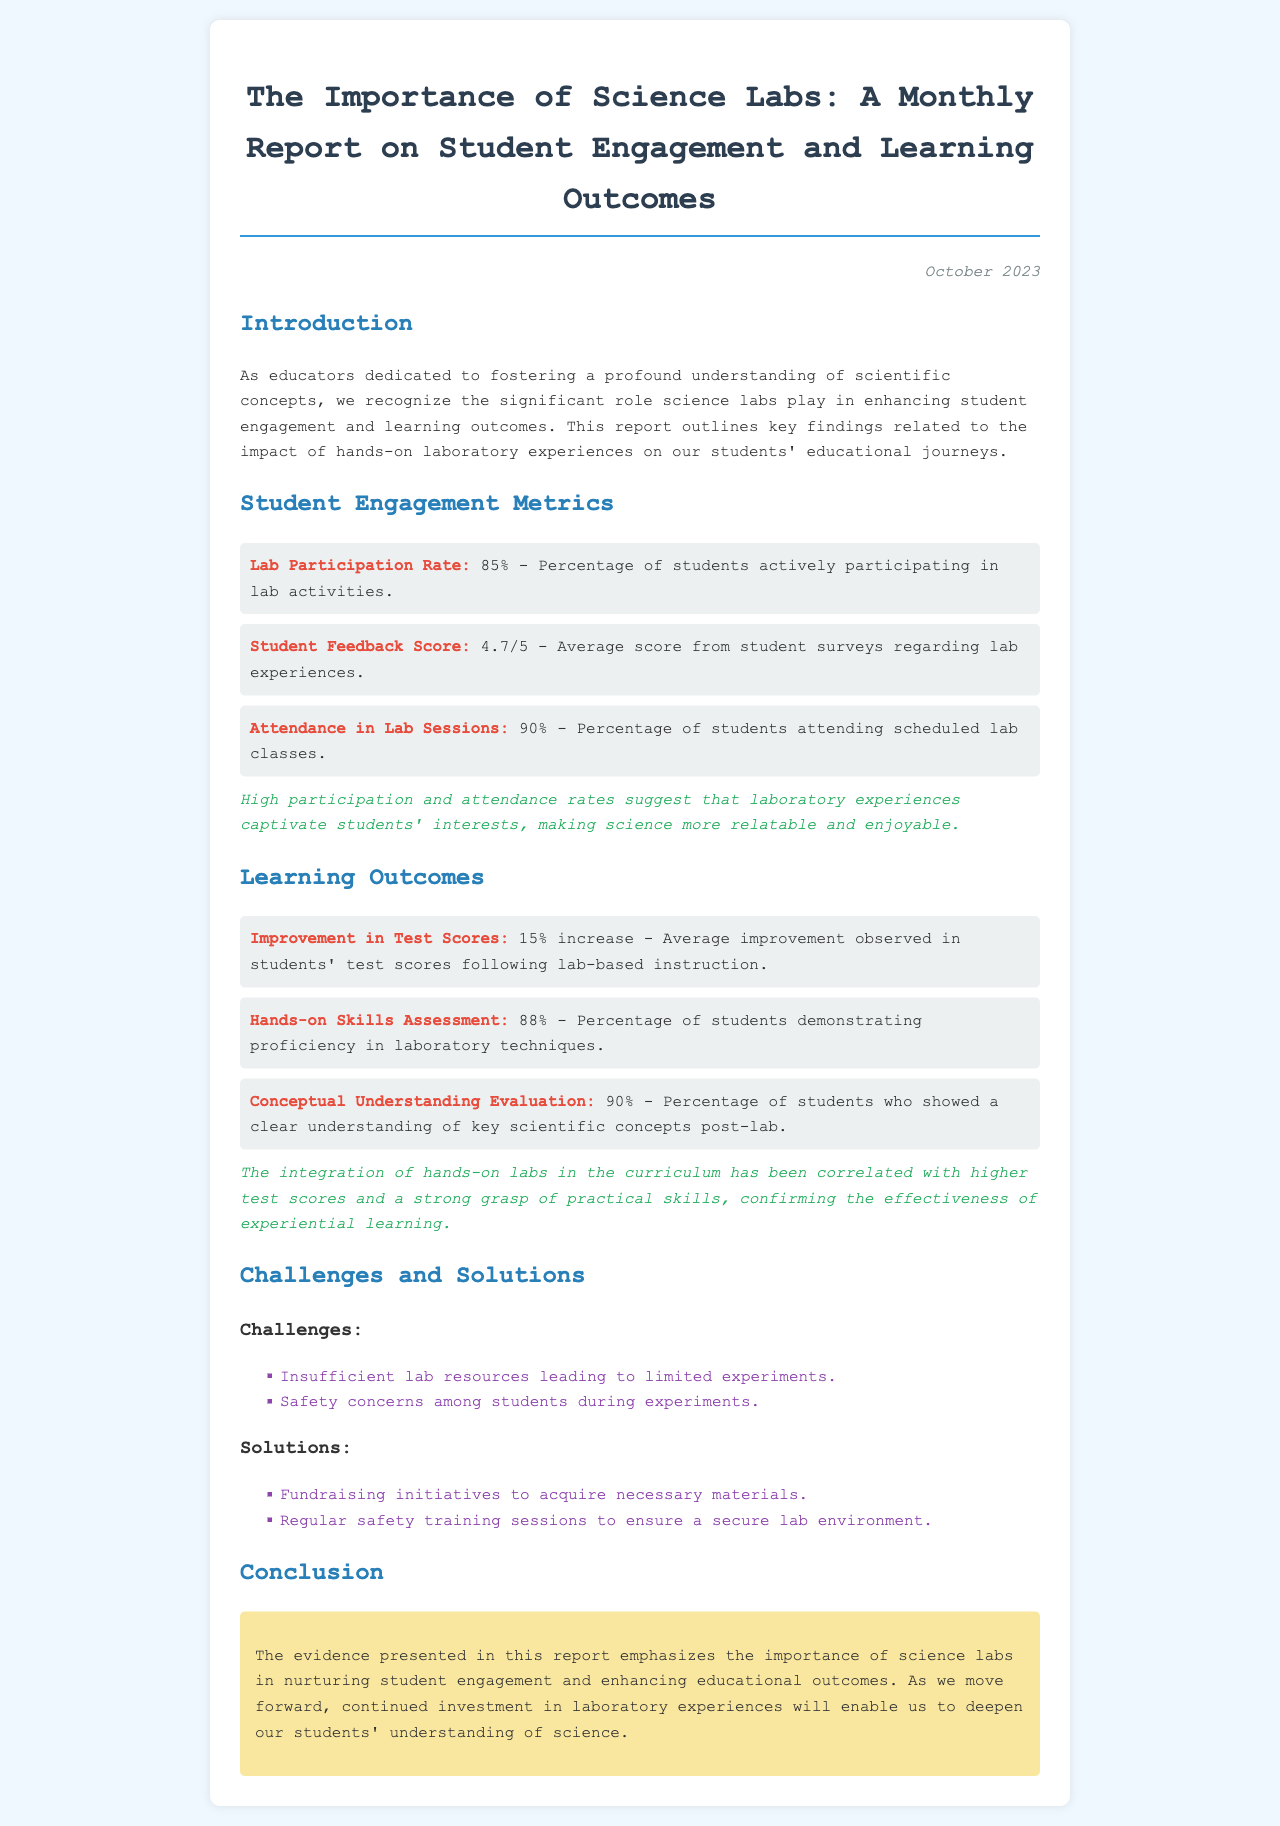What is the Lab Participation Rate? The Lab Participation Rate is the percentage of students actively participating in lab activities, which is provided in the metrics section of the document.
Answer: 85% What is the average Student Feedback Score? The average Student Feedback Score reflects students' satisfaction with lab experiences, as outlined in the metrics section.
Answer: 4.7/5 What percentage of students attended Lab Sessions? This percentage indicates how many students were present during scheduled lab classes, mentioned in the document.
Answer: 90% What was the improvement in Test Scores after lab-based instruction? This figure represents the average increase in students' test scores following instructional labs, found in the learning outcomes.
Answer: 15% increase What percentage of students demonstrated proficiency in laboratory techniques? This percentage indicates student skill level in lab techniques, as highlighted in the learning outcomes section.
Answer: 88% What challenges are mentioned in the report? These are specific obstacles faced in the science labs, noted in the challenges section of the document.
Answer: Insufficient lab resources and Safety concerns How does the report suggest addressing lab resource challenges? This offers solutions to the challenges outlined, indicating steps for improvement in the lab environment.
Answer: Fundraising initiatives What is the main conclusion of the report? This summarizes the overall findings regarding the importance of science labs, found in the conclusion section.
Answer: Importance of science labs in nurturing student engagement and enhancing educational outcomes 